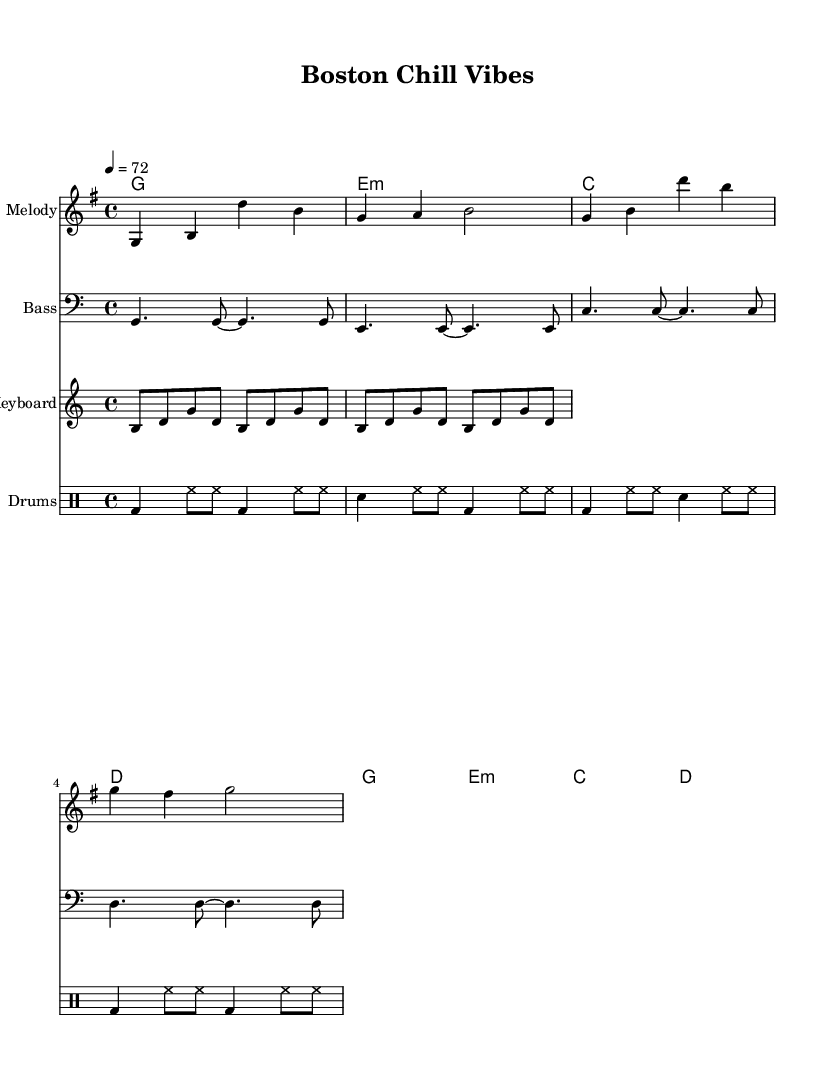What is the key signature of this music? The key signature indicated is G major, which has one sharp (F#). You can identify this from the key signature at the beginning of the sheet music, right after the clef sign.
Answer: G major What is the time signature of this piece? The time signature shown is 4/4, which is indicated at the beginning of the score. In 4/4 time, there are four beats in each measure, and the quarter note gets one beat.
Answer: 4/4 What is the tempo marking for the piece? The tempo marking is 4 = 72, meaning that there are 72 quarter note beats per minute. This indicates a moderate pace, enhancing the laid-back feel typical of reggae music. You can find this marking right at the start of the score.
Answer: 72 How many measures are present in the melody section? Counting the measures in the melody staff shows that there are eight measures in total. This is done by visually identifying the bar lines that separate each measure.
Answer: 8 What type of chords are used in the chord progression? The chord progression comprises major and minor chords, specifically G major, E minor, C major, and D major, which can be seen written in the chord names section. This progression contributes to the characteristic sound of reggae music.
Answer: Major and minor How is the bass line structured in terms of rhythm? The bass line features a mix of dotted quarter notes and eighth notes, creating a syncopated rhythmic feel typical in reggae music. The dotted notes add a laid-back groove while maintaining a steady pulse. You can observe this through the rhythmic notation in the bass staff.
Answer: Syncopated Which instrument plays the melody? The melody is played by the instrument labeled "Melody," which is typically a melodic instrument such as a flute or guitar in reggae. This is indicated by the instrument name written at the beginning of the staff for the melody.
Answer: Melody 